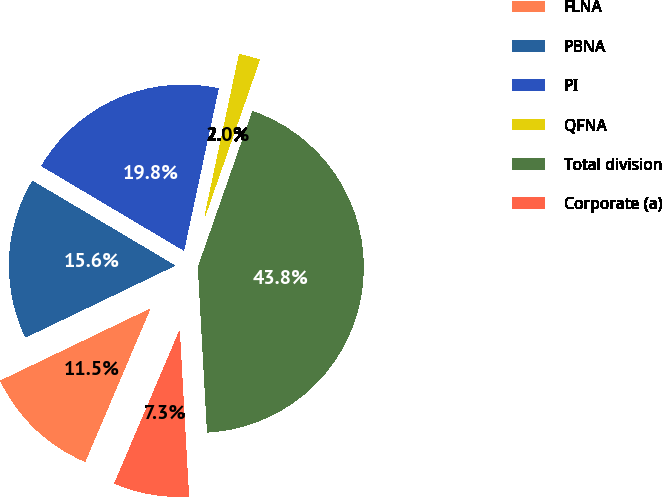Convert chart. <chart><loc_0><loc_0><loc_500><loc_500><pie_chart><fcel>FLNA<fcel>PBNA<fcel>PI<fcel>QFNA<fcel>Total division<fcel>Corporate (a)<nl><fcel>11.47%<fcel>15.65%<fcel>19.82%<fcel>2.0%<fcel>43.77%<fcel>7.29%<nl></chart> 